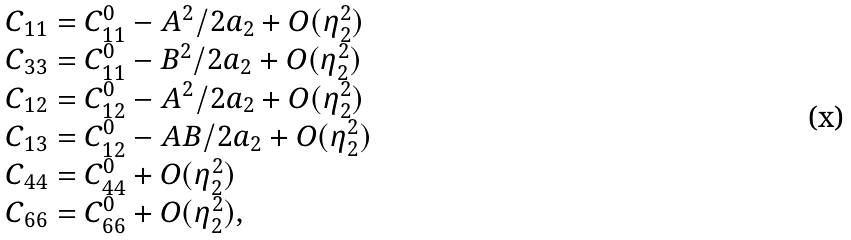<formula> <loc_0><loc_0><loc_500><loc_500>\begin{array} { l } C _ { 1 1 } = C _ { 1 1 } ^ { 0 } - A ^ { 2 } / 2 a _ { 2 } + O ( \eta _ { 2 } ^ { 2 } ) \\ C _ { 3 3 } = C _ { 1 1 } ^ { 0 } - B ^ { 2 } / 2 a _ { 2 } + O ( \eta _ { 2 } ^ { 2 } ) \\ C _ { 1 2 } = C _ { 1 2 } ^ { 0 } - A ^ { 2 } / 2 a _ { 2 } + O ( \eta _ { 2 } ^ { 2 } ) \\ C _ { 1 3 } = C _ { 1 2 } ^ { 0 } - A B / 2 a _ { 2 } + O ( \eta _ { 2 } ^ { 2 } ) \\ C _ { 4 4 } = C _ { 4 4 } ^ { 0 } + O ( \eta _ { 2 } ^ { 2 } ) \\ C _ { 6 6 } = C _ { 6 6 } ^ { 0 } + O ( \eta _ { 2 } ^ { 2 } ) , \end{array}</formula> 